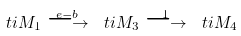<formula> <loc_0><loc_0><loc_500><loc_500>\ t i M _ { 1 } \overset { e - b } { \longrightarrow } \ t i M _ { 3 } \overset { 1 } { \longrightarrow } \ t i M _ { 4 }</formula> 